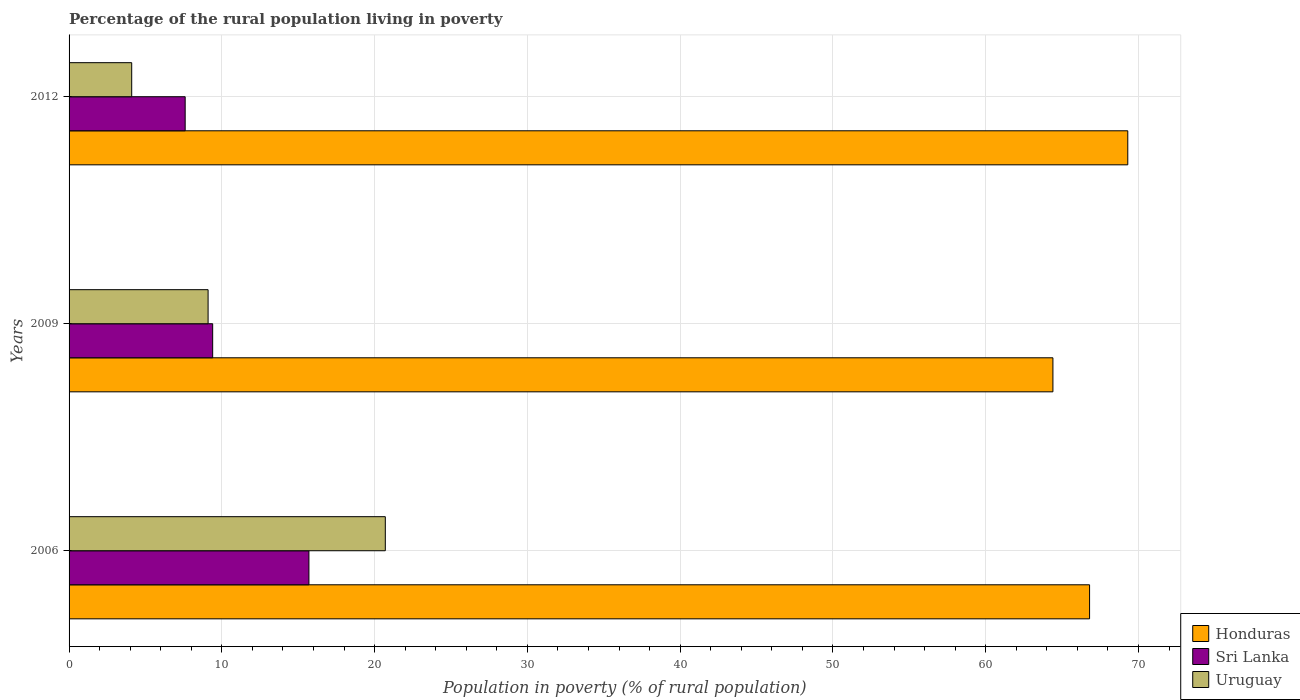How many different coloured bars are there?
Offer a terse response. 3. How many groups of bars are there?
Provide a succinct answer. 3. Are the number of bars per tick equal to the number of legend labels?
Your response must be concise. Yes. Are the number of bars on each tick of the Y-axis equal?
Offer a very short reply. Yes. What is the label of the 2nd group of bars from the top?
Ensure brevity in your answer.  2009. In how many cases, is the number of bars for a given year not equal to the number of legend labels?
Offer a terse response. 0. What is the percentage of the rural population living in poverty in Uruguay in 2012?
Your response must be concise. 4.1. What is the total percentage of the rural population living in poverty in Sri Lanka in the graph?
Provide a succinct answer. 32.7. What is the difference between the percentage of the rural population living in poverty in Sri Lanka in 2006 and the percentage of the rural population living in poverty in Honduras in 2012?
Offer a very short reply. -53.6. What is the average percentage of the rural population living in poverty in Uruguay per year?
Keep it short and to the point. 11.3. In the year 2009, what is the difference between the percentage of the rural population living in poverty in Honduras and percentage of the rural population living in poverty in Sri Lanka?
Keep it short and to the point. 55. What is the ratio of the percentage of the rural population living in poverty in Sri Lanka in 2009 to that in 2012?
Your response must be concise. 1.24. Is the percentage of the rural population living in poverty in Honduras in 2006 less than that in 2009?
Offer a terse response. No. Is the difference between the percentage of the rural population living in poverty in Honduras in 2009 and 2012 greater than the difference between the percentage of the rural population living in poverty in Sri Lanka in 2009 and 2012?
Your answer should be compact. No. What is the difference between the highest and the lowest percentage of the rural population living in poverty in Honduras?
Your answer should be very brief. 4.9. In how many years, is the percentage of the rural population living in poverty in Honduras greater than the average percentage of the rural population living in poverty in Honduras taken over all years?
Provide a succinct answer. 1. What does the 2nd bar from the top in 2012 represents?
Your response must be concise. Sri Lanka. What does the 1st bar from the bottom in 2009 represents?
Ensure brevity in your answer.  Honduras. Is it the case that in every year, the sum of the percentage of the rural population living in poverty in Honduras and percentage of the rural population living in poverty in Uruguay is greater than the percentage of the rural population living in poverty in Sri Lanka?
Offer a very short reply. Yes. How many bars are there?
Provide a succinct answer. 9. Does the graph contain grids?
Make the answer very short. Yes. How many legend labels are there?
Make the answer very short. 3. What is the title of the graph?
Provide a succinct answer. Percentage of the rural population living in poverty. What is the label or title of the X-axis?
Offer a very short reply. Population in poverty (% of rural population). What is the Population in poverty (% of rural population) of Honduras in 2006?
Keep it short and to the point. 66.8. What is the Population in poverty (% of rural population) in Uruguay in 2006?
Provide a succinct answer. 20.7. What is the Population in poverty (% of rural population) of Honduras in 2009?
Give a very brief answer. 64.4. What is the Population in poverty (% of rural population) in Sri Lanka in 2009?
Keep it short and to the point. 9.4. What is the Population in poverty (% of rural population) in Honduras in 2012?
Provide a succinct answer. 69.3. What is the Population in poverty (% of rural population) in Uruguay in 2012?
Offer a very short reply. 4.1. Across all years, what is the maximum Population in poverty (% of rural population) in Honduras?
Provide a succinct answer. 69.3. Across all years, what is the maximum Population in poverty (% of rural population) of Sri Lanka?
Your response must be concise. 15.7. Across all years, what is the maximum Population in poverty (% of rural population) of Uruguay?
Offer a very short reply. 20.7. Across all years, what is the minimum Population in poverty (% of rural population) in Honduras?
Your answer should be very brief. 64.4. Across all years, what is the minimum Population in poverty (% of rural population) of Uruguay?
Make the answer very short. 4.1. What is the total Population in poverty (% of rural population) in Honduras in the graph?
Ensure brevity in your answer.  200.5. What is the total Population in poverty (% of rural population) of Sri Lanka in the graph?
Your response must be concise. 32.7. What is the total Population in poverty (% of rural population) in Uruguay in the graph?
Provide a short and direct response. 33.9. What is the difference between the Population in poverty (% of rural population) of Honduras in 2006 and that in 2009?
Your answer should be compact. 2.4. What is the difference between the Population in poverty (% of rural population) of Sri Lanka in 2006 and that in 2009?
Your answer should be very brief. 6.3. What is the difference between the Population in poverty (% of rural population) of Honduras in 2006 and that in 2012?
Ensure brevity in your answer.  -2.5. What is the difference between the Population in poverty (% of rural population) in Honduras in 2009 and that in 2012?
Your answer should be very brief. -4.9. What is the difference between the Population in poverty (% of rural population) in Honduras in 2006 and the Population in poverty (% of rural population) in Sri Lanka in 2009?
Give a very brief answer. 57.4. What is the difference between the Population in poverty (% of rural population) of Honduras in 2006 and the Population in poverty (% of rural population) of Uruguay in 2009?
Provide a short and direct response. 57.7. What is the difference between the Population in poverty (% of rural population) of Sri Lanka in 2006 and the Population in poverty (% of rural population) of Uruguay in 2009?
Give a very brief answer. 6.6. What is the difference between the Population in poverty (% of rural population) in Honduras in 2006 and the Population in poverty (% of rural population) in Sri Lanka in 2012?
Provide a succinct answer. 59.2. What is the difference between the Population in poverty (% of rural population) in Honduras in 2006 and the Population in poverty (% of rural population) in Uruguay in 2012?
Your answer should be very brief. 62.7. What is the difference between the Population in poverty (% of rural population) of Honduras in 2009 and the Population in poverty (% of rural population) of Sri Lanka in 2012?
Keep it short and to the point. 56.8. What is the difference between the Population in poverty (% of rural population) in Honduras in 2009 and the Population in poverty (% of rural population) in Uruguay in 2012?
Give a very brief answer. 60.3. What is the average Population in poverty (% of rural population) of Honduras per year?
Your answer should be very brief. 66.83. What is the average Population in poverty (% of rural population) of Sri Lanka per year?
Offer a very short reply. 10.9. In the year 2006, what is the difference between the Population in poverty (% of rural population) of Honduras and Population in poverty (% of rural population) of Sri Lanka?
Offer a very short reply. 51.1. In the year 2006, what is the difference between the Population in poverty (% of rural population) of Honduras and Population in poverty (% of rural population) of Uruguay?
Your answer should be compact. 46.1. In the year 2009, what is the difference between the Population in poverty (% of rural population) in Honduras and Population in poverty (% of rural population) in Uruguay?
Offer a very short reply. 55.3. In the year 2012, what is the difference between the Population in poverty (% of rural population) in Honduras and Population in poverty (% of rural population) in Sri Lanka?
Your answer should be very brief. 61.7. In the year 2012, what is the difference between the Population in poverty (% of rural population) in Honduras and Population in poverty (% of rural population) in Uruguay?
Your response must be concise. 65.2. What is the ratio of the Population in poverty (% of rural population) in Honduras in 2006 to that in 2009?
Make the answer very short. 1.04. What is the ratio of the Population in poverty (% of rural population) in Sri Lanka in 2006 to that in 2009?
Provide a succinct answer. 1.67. What is the ratio of the Population in poverty (% of rural population) of Uruguay in 2006 to that in 2009?
Provide a short and direct response. 2.27. What is the ratio of the Population in poverty (% of rural population) in Honduras in 2006 to that in 2012?
Offer a terse response. 0.96. What is the ratio of the Population in poverty (% of rural population) in Sri Lanka in 2006 to that in 2012?
Keep it short and to the point. 2.07. What is the ratio of the Population in poverty (% of rural population) of Uruguay in 2006 to that in 2012?
Your response must be concise. 5.05. What is the ratio of the Population in poverty (% of rural population) of Honduras in 2009 to that in 2012?
Provide a short and direct response. 0.93. What is the ratio of the Population in poverty (% of rural population) in Sri Lanka in 2009 to that in 2012?
Provide a succinct answer. 1.24. What is the ratio of the Population in poverty (% of rural population) of Uruguay in 2009 to that in 2012?
Your response must be concise. 2.22. What is the difference between the highest and the second highest Population in poverty (% of rural population) of Honduras?
Give a very brief answer. 2.5. What is the difference between the highest and the second highest Population in poverty (% of rural population) in Uruguay?
Ensure brevity in your answer.  11.6. What is the difference between the highest and the lowest Population in poverty (% of rural population) of Honduras?
Offer a terse response. 4.9. What is the difference between the highest and the lowest Population in poverty (% of rural population) of Uruguay?
Make the answer very short. 16.6. 